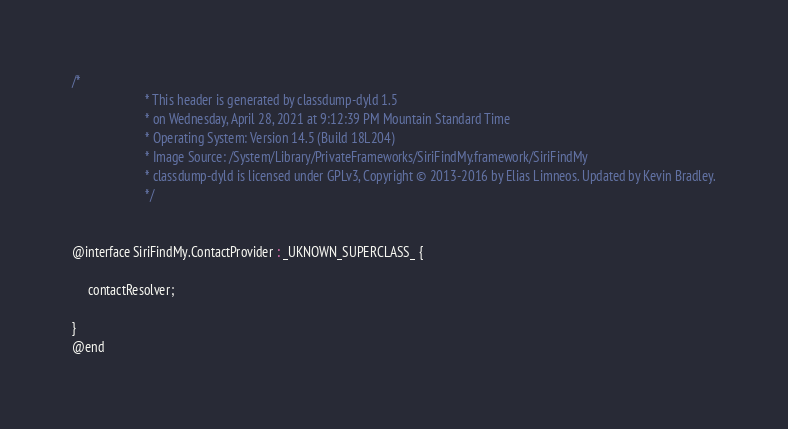Convert code to text. <code><loc_0><loc_0><loc_500><loc_500><_C_>/*
                       * This header is generated by classdump-dyld 1.5
                       * on Wednesday, April 28, 2021 at 9:12:39 PM Mountain Standard Time
                       * Operating System: Version 14.5 (Build 18L204)
                       * Image Source: /System/Library/PrivateFrameworks/SiriFindMy.framework/SiriFindMy
                       * classdump-dyld is licensed under GPLv3, Copyright © 2013-2016 by Elias Limneos. Updated by Kevin Bradley.
                       */


@interface SiriFindMy.ContactProvider : _UKNOWN_SUPERCLASS_ {

	 contactResolver;

}
@end

</code> 